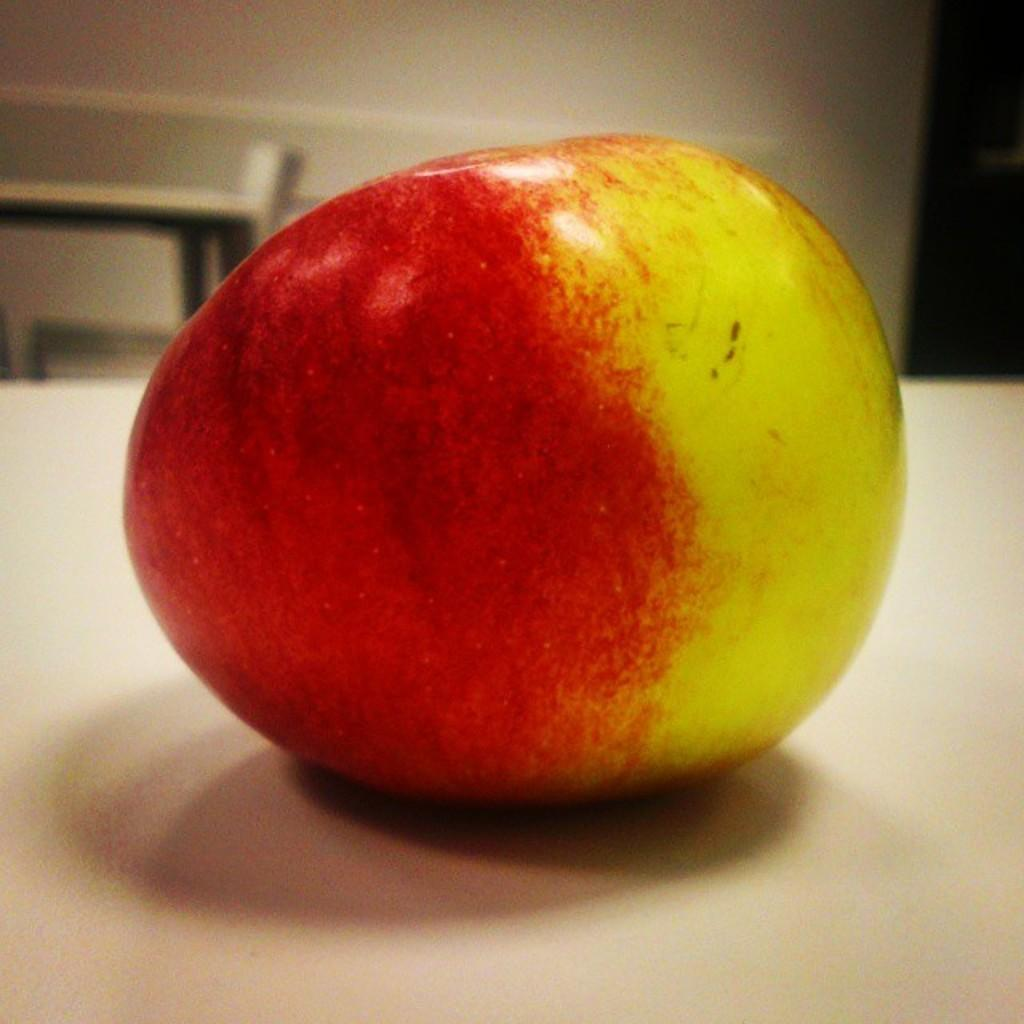What is the main subject of the image? There is an apple on a white surface in the image. Can you describe the background of the image? The background of the image is blurred. What type of prose is being written on the apple in the image? There is no prose or writing present on the apple in the image. 